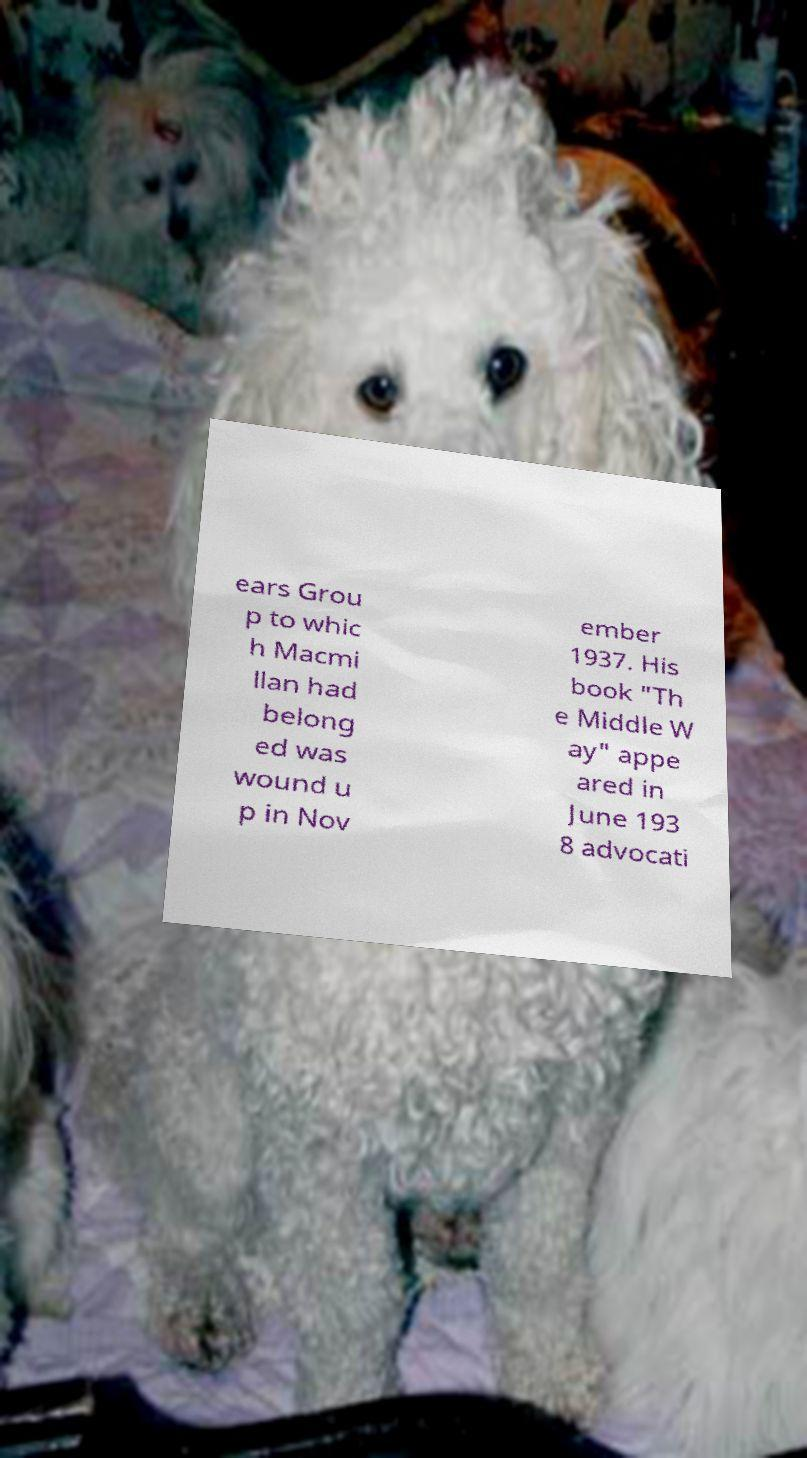For documentation purposes, I need the text within this image transcribed. Could you provide that? ears Grou p to whic h Macmi llan had belong ed was wound u p in Nov ember 1937. His book "Th e Middle W ay" appe ared in June 193 8 advocati 